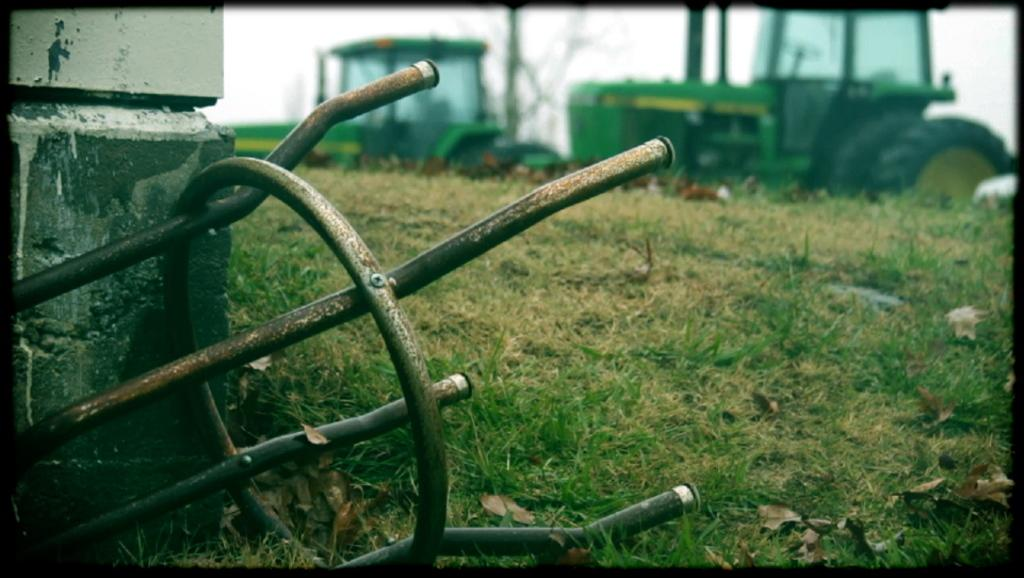What types of objects can be seen in the image? There are vehicles, leaves, and grass in the image. What else can be found on the ground in the image? There are other objects on the ground in the image. What is visible in the background of the image? The sky is visible in the image. How many family members are present in the image? There is no family present in the image; it only features vehicles, leaves, grass, and other objects on the ground. What types of toys can be seen in the image? There are no toys present in the image. 